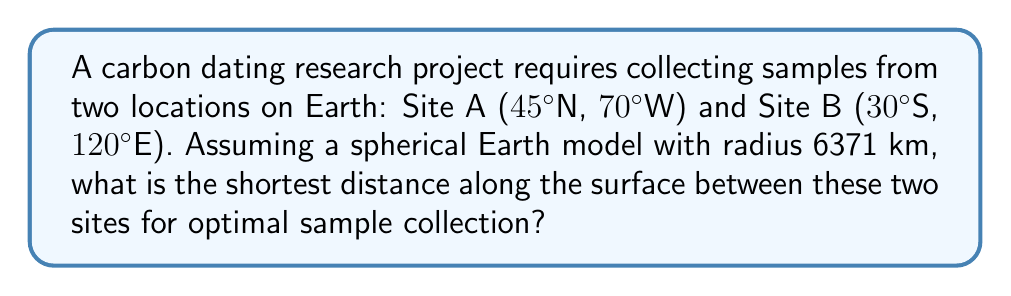What is the answer to this math problem? To solve this problem, we'll use the great circle distance formula, which gives the shortest path between two points on a sphere. The steps are as follows:

1. Convert the coordinates to radians:
   Site A: $\phi_1 = 45° \cdot \frac{\pi}{180} = 0.7854$ rad, $\lambda_1 = -70° \cdot \frac{\pi}{180} = -1.2217$ rad
   Site B: $\phi_2 = -30° \cdot \frac{\pi}{180} = -0.5236$ rad, $\lambda_2 = 120° \cdot \frac{\pi}{180} = 2.0944$ rad

2. Calculate the central angle $\Delta\sigma$ using the Haversine formula:
   $$\Delta\sigma = 2 \arcsin\left(\sqrt{\sin^2\left(\frac{\phi_2 - \phi_1}{2}\right) + \cos\phi_1 \cos\phi_2 \sin^2\left(\frac{\lambda_2 - \lambda_1}{2}\right)}\right)$$

3. Substitute the values:
   $$\Delta\sigma = 2 \arcsin\left(\sqrt{\sin^2\left(\frac{-0.5236 - 0.7854}{2}\right) + \cos(0.7854) \cos(-0.5236) \sin^2\left(\frac{2.0944 - (-1.2217)}{2}\right)}\right)$$

4. Calculate the result:
   $$\Delta\sigma \approx 2.6876 \text{ radians}$$

5. Multiply by Earth's radius to get the distance:
   $$d = R \cdot \Delta\sigma = 6371 \text{ km} \cdot 2.6876 \approx 17122 \text{ km}$$

[asy]
import geometry;

size(200);
draw(circle((0,0),1));
dot((0.7071,0.7071),red);
label("A",(0.7071,0.7071),NE,red);
dot((-0.866,-0.5),blue);
label("B",(-0.866,-0.5),SW,blue);
draw((0.7071,0.7071)--(-0.866,-0.5),green);
[/asy]
Answer: 17122 km 